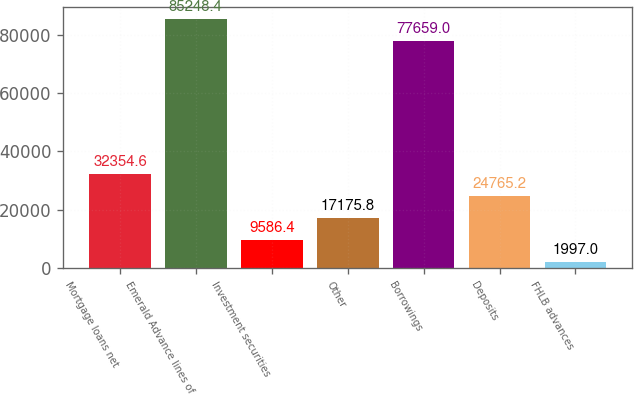<chart> <loc_0><loc_0><loc_500><loc_500><bar_chart><fcel>Mortgage loans net<fcel>Emerald Advance lines of<fcel>Investment securities<fcel>Other<fcel>Borrowings<fcel>Deposits<fcel>FHLB advances<nl><fcel>32354.6<fcel>85248.4<fcel>9586.4<fcel>17175.8<fcel>77659<fcel>24765.2<fcel>1997<nl></chart> 